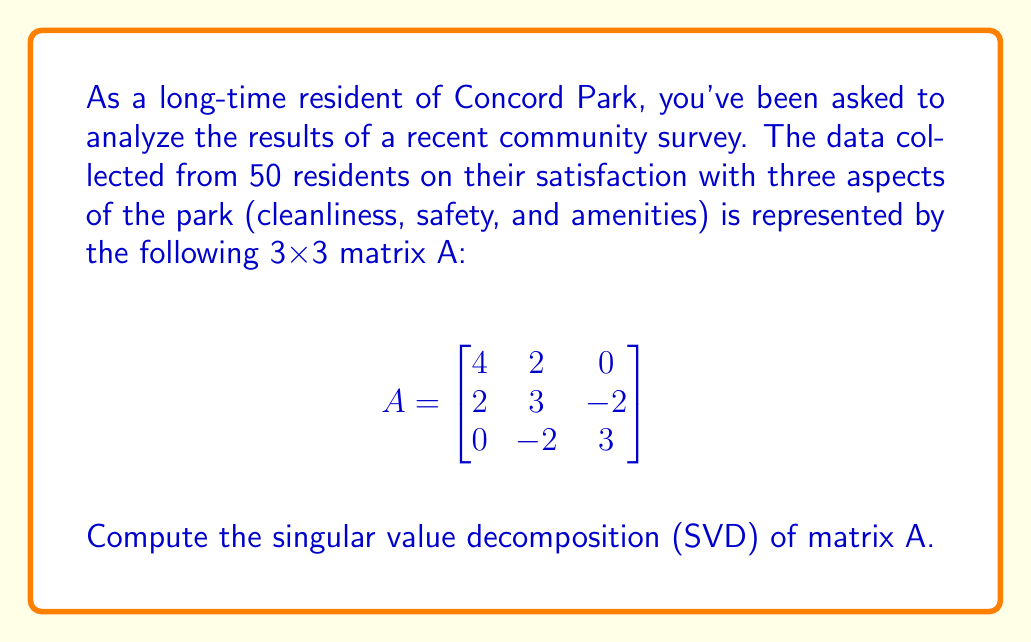What is the answer to this math problem? To find the singular value decomposition of matrix A, we need to follow these steps:

1) First, calculate $A^TA$:
   $$A^TA = \begin{bmatrix}
   4 & 2 & 0 \\
   2 & 3 & -2 \\
   0 & -2 & 3
   \end{bmatrix}
   \begin{bmatrix}
   4 & 2 & 0 \\
   2 & 3 & -2 \\
   0 & -2 & 3
   \end{bmatrix}
   = \begin{bmatrix}
   20 & 14 & -4 \\
   14 & 17 & -10 \\
   -4 & -10 & 13
   \end{bmatrix}$$

2) Find the eigenvalues of $A^TA$ by solving the characteristic equation:
   $\det(A^TA - \lambda I) = 0$
   
   This gives us: $-\lambda^3 + 50\lambda^2 - 519\lambda + 900 = 0$
   
   Solving this equation, we get eigenvalues: $\lambda_1 = 36, \lambda_2 = 9, \lambda_3 = 5$

3) The singular values are the square roots of these eigenvalues:
   $\sigma_1 = 6, \sigma_2 = 3, \sigma_3 = \sqrt{5}$

4) Now, we need to find the right singular vectors (eigenvectors of $A^TA$):
   For $\lambda_1 = 36$: $v_1 = [2/3, 2/3, -1/3]^T$
   For $\lambda_2 = 9$:  $v_2 = [-1/\sqrt{2}, 1/\sqrt{2}, 0]^T$
   For $\lambda_3 = 5$:  $v_3 = [1/3, 1/3, 2/3]^T$

5) The left singular vectors are given by $u_i = Av_i / \sigma_i$:
   $u_1 = [2/3, 2/3, -1/3]^T$
   $u_2 = [-1/\sqrt{2}, 1/\sqrt{2}, 0]^T$
   $u_3 = [-1/3, 1/3, 2/3]^T$

6) The SVD of A is given by $A = U\Sigma V^T$, where:
   $U = [u_1 | u_2 | u_3]$
   $\Sigma = \text{diag}(\sigma_1, \sigma_2, \sigma_3)$
   $V = [v_1 | v_2 | v_3]$
Answer: $A = U\Sigma V^T$, where
$U = \begin{bmatrix}
2/3 & -1/\sqrt{2} & -1/3 \\
2/3 & 1/\sqrt{2} & 1/3 \\
-1/3 & 0 & 2/3
\end{bmatrix}$,
$\Sigma = \begin{bmatrix}
6 & 0 & 0 \\
0 & 3 & 0 \\
0 & 0 & \sqrt{5}
\end{bmatrix}$,
$V = \begin{bmatrix}
2/3 & -1/\sqrt{2} & 1/3 \\
2/3 & 1/\sqrt{2} & 1/3 \\
-1/3 & 0 & 2/3
\end{bmatrix}$ 